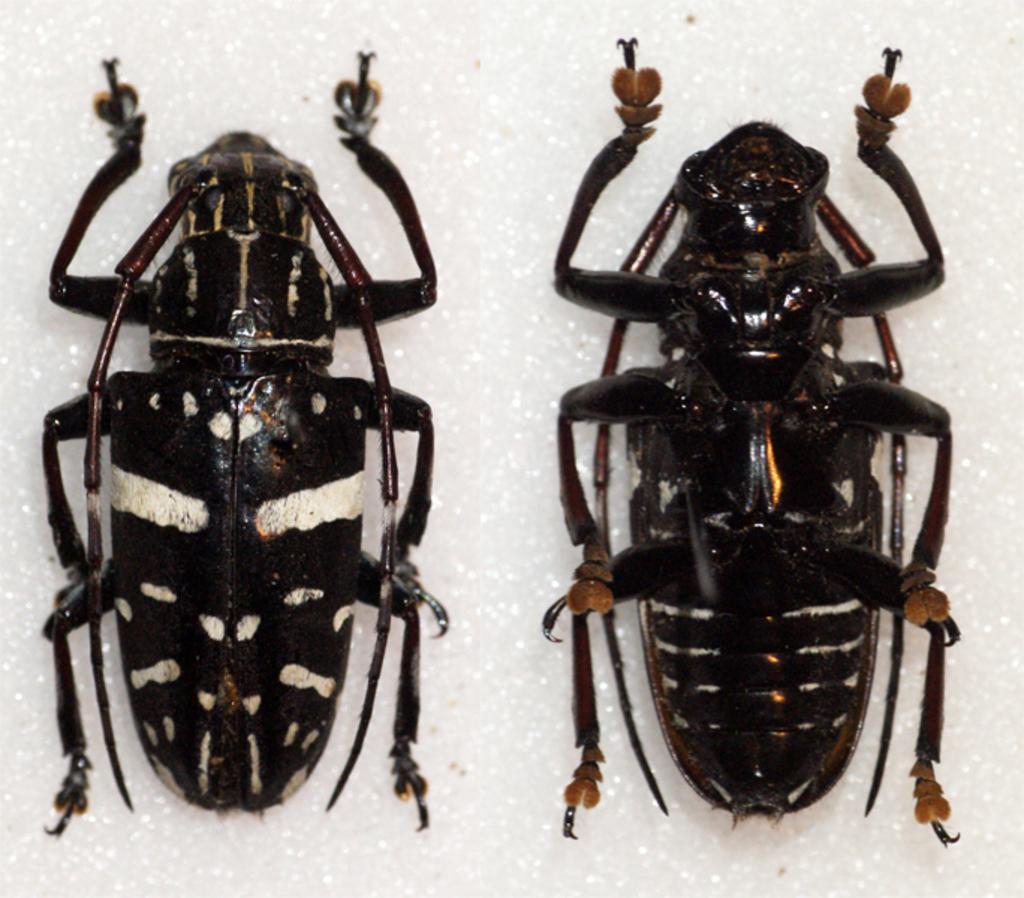How would you summarize this image in a sentence or two? In this picture, we can see two ants which are in black color and the background is in white color. 